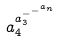Convert formula to latex. <formula><loc_0><loc_0><loc_500><loc_500>a _ { 4 } ^ { a _ { 3 } ^ { - ^ { - ^ { a _ { n } } } } }</formula> 